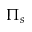Convert formula to latex. <formula><loc_0><loc_0><loc_500><loc_500>\Pi _ { s }</formula> 